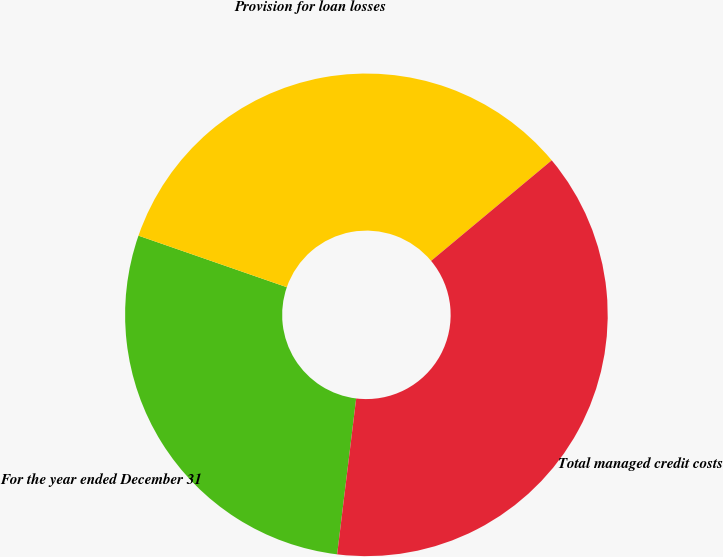Convert chart. <chart><loc_0><loc_0><loc_500><loc_500><pie_chart><fcel>For the year ended December 31<fcel>Provision for loan losses<fcel>Total managed credit costs<nl><fcel>28.39%<fcel>33.62%<fcel>38.0%<nl></chart> 